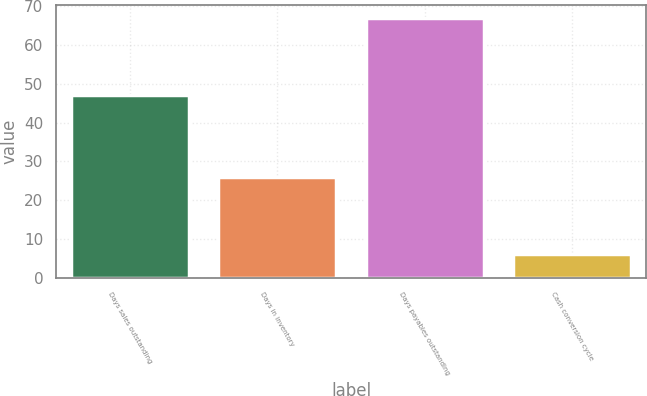Convert chart. <chart><loc_0><loc_0><loc_500><loc_500><bar_chart><fcel>Days sales outstanding<fcel>Days in inventory<fcel>Days payables outstanding<fcel>Cash conversion cycle<nl><fcel>47<fcel>26<fcel>67<fcel>6<nl></chart> 